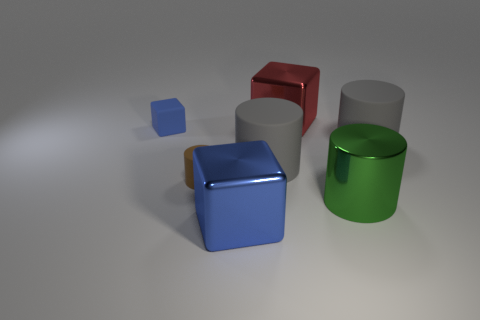What number of other things are there of the same color as the tiny matte cube?
Keep it short and to the point. 1. There is a cube that is the same size as the blue shiny object; what is its material?
Give a very brief answer. Metal. How big is the block that is in front of the big red object and behind the big blue object?
Make the answer very short. Small. What material is the other blue thing that is the same shape as the tiny blue object?
Your answer should be very brief. Metal. Do the block that is in front of the small blue object and the tiny rubber thing that is left of the tiny brown matte cylinder have the same color?
Provide a succinct answer. Yes. The small cylinder is what color?
Make the answer very short. Brown. There is a green metallic thing on the right side of the red object; does it have the same size as the small brown cylinder?
Keep it short and to the point. No. There is a metallic object that is on the left side of the large red block; is it the same color as the tiny matte cube?
Give a very brief answer. Yes. There is a small blue rubber object; what shape is it?
Give a very brief answer. Cube. How many other objects are the same shape as the big red metal object?
Make the answer very short. 2. 